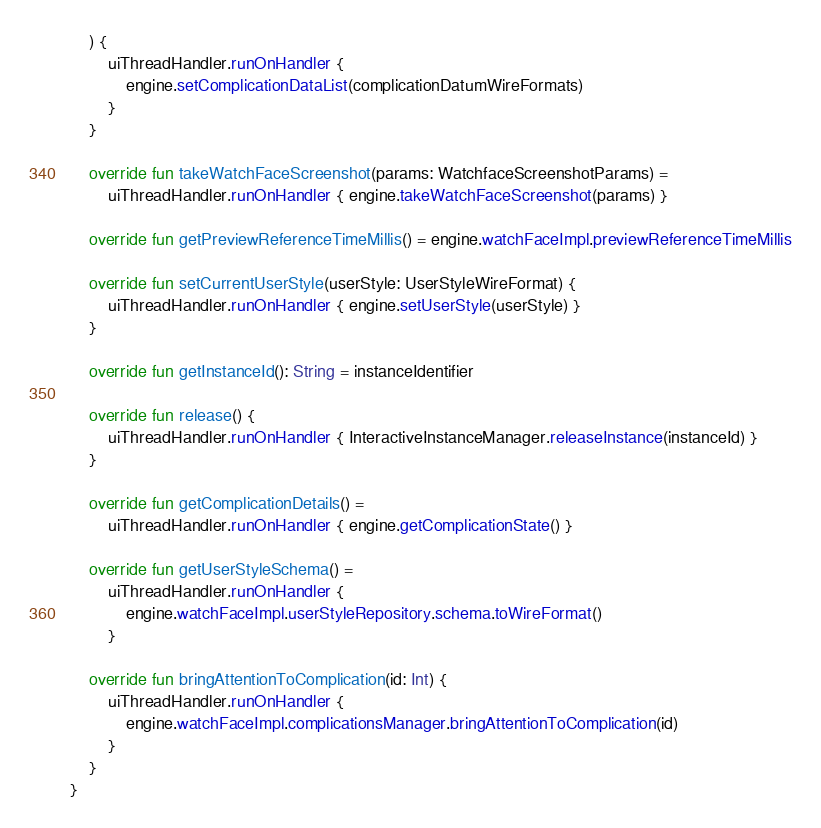<code> <loc_0><loc_0><loc_500><loc_500><_Kotlin_>    ) {
        uiThreadHandler.runOnHandler {
            engine.setComplicationDataList(complicationDatumWireFormats)
        }
    }

    override fun takeWatchFaceScreenshot(params: WatchfaceScreenshotParams) =
        uiThreadHandler.runOnHandler { engine.takeWatchFaceScreenshot(params) }

    override fun getPreviewReferenceTimeMillis() = engine.watchFaceImpl.previewReferenceTimeMillis

    override fun setCurrentUserStyle(userStyle: UserStyleWireFormat) {
        uiThreadHandler.runOnHandler { engine.setUserStyle(userStyle) }
    }

    override fun getInstanceId(): String = instanceIdentifier

    override fun release() {
        uiThreadHandler.runOnHandler { InteractiveInstanceManager.releaseInstance(instanceId) }
    }

    override fun getComplicationDetails() =
        uiThreadHandler.runOnHandler { engine.getComplicationState() }

    override fun getUserStyleSchema() =
        uiThreadHandler.runOnHandler {
            engine.watchFaceImpl.userStyleRepository.schema.toWireFormat()
        }

    override fun bringAttentionToComplication(id: Int) {
        uiThreadHandler.runOnHandler {
            engine.watchFaceImpl.complicationsManager.bringAttentionToComplication(id)
        }
    }
}</code> 